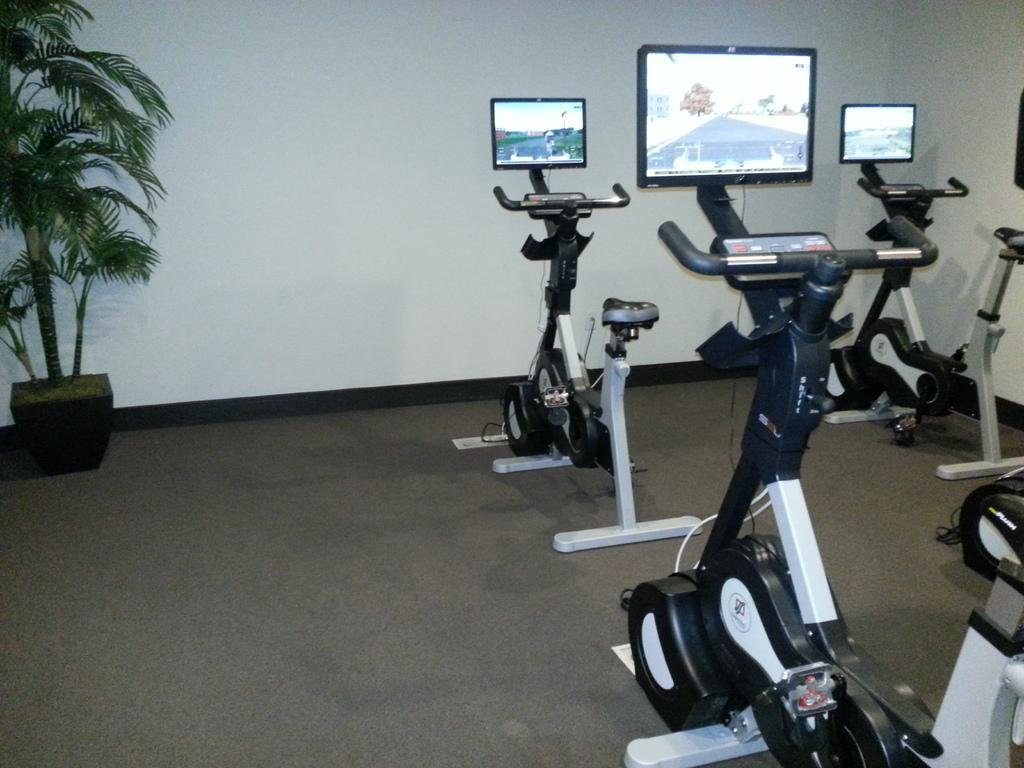What type of equipment is visible in the image? There are exercise cycles in the image. Where are the exercise cycles located in the image? The exercise cycles are located towards the right side of the image. What feature do the exercise cycles have? Each exercise cycle has a screen. What type of vegetation is present in the image? There is a plant in a pot in the image. Where is the plant located in the image? The plant is located towards the left side of the image. What can be seen in the background of the image? There is a wall in the background of the image. How many frogs are sitting on the exercise cycles in the image? There are no frogs present in the image; it features exercise cycles and a plant. What type of gun is visible on the wall in the image? There is no gun visible on the wall in the image; it only shows a wall in the background. 